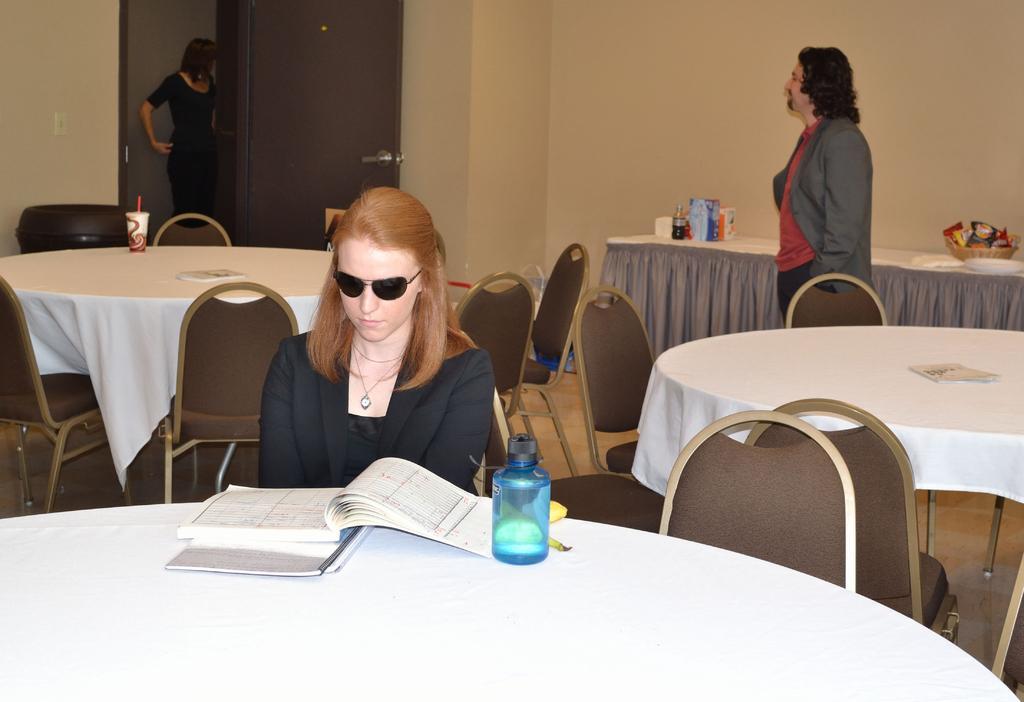Can you describe this image briefly? In this picture there is a woman in the center besides a table. On the table there are books and bottle. She is wearing a black blazer and black goggles. The room is filled with the empty chairs and tables. Towards the right there is a man, he is wearing a red t shirt and grey blazer. He is staring at another woman, she is wearing a black dress. Besides the wall, there is a table, on the table there are bottles and snacks. 